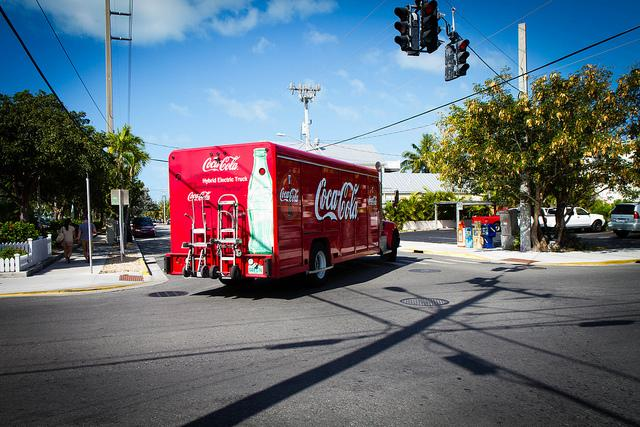Where is the truck going?

Choices:
A) store
B) bank
C) beach
D) restaurant store 